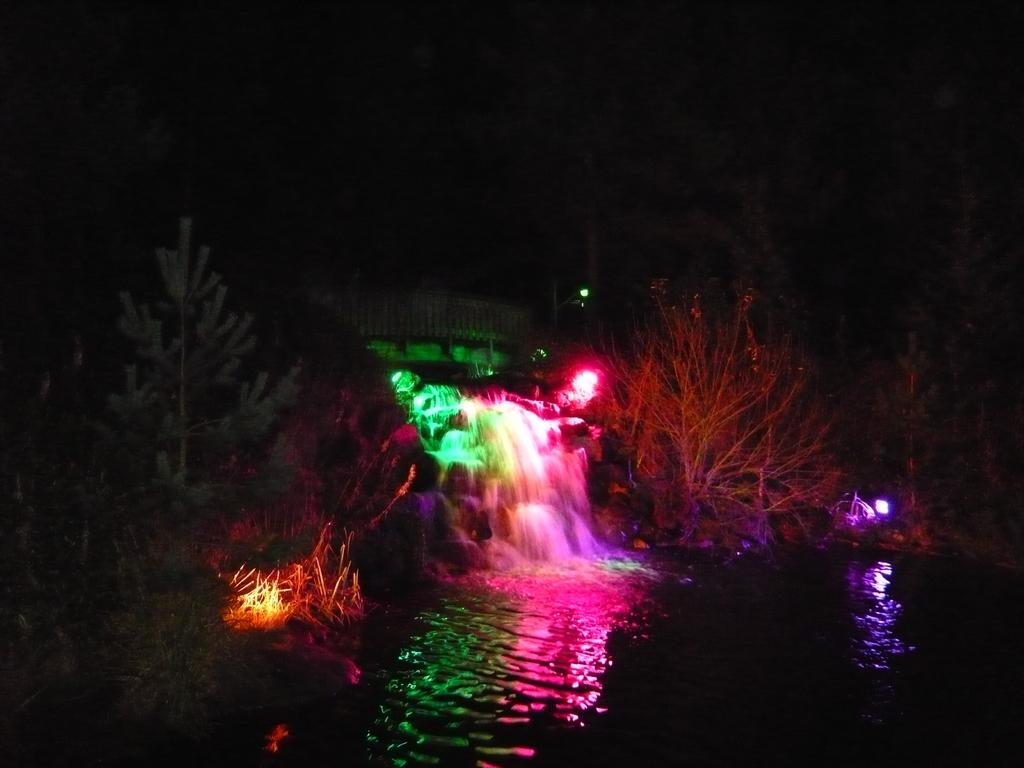What is visible in the image? Water and trees are visible in the image. Are there any additional features in the image? Yes, colorful lights are present in the image. What type of sink is visible in the image? There is no sink present in the image. What color is the sky in the image? The provided facts do not mention the sky, so we cannot determine its color from the image. 